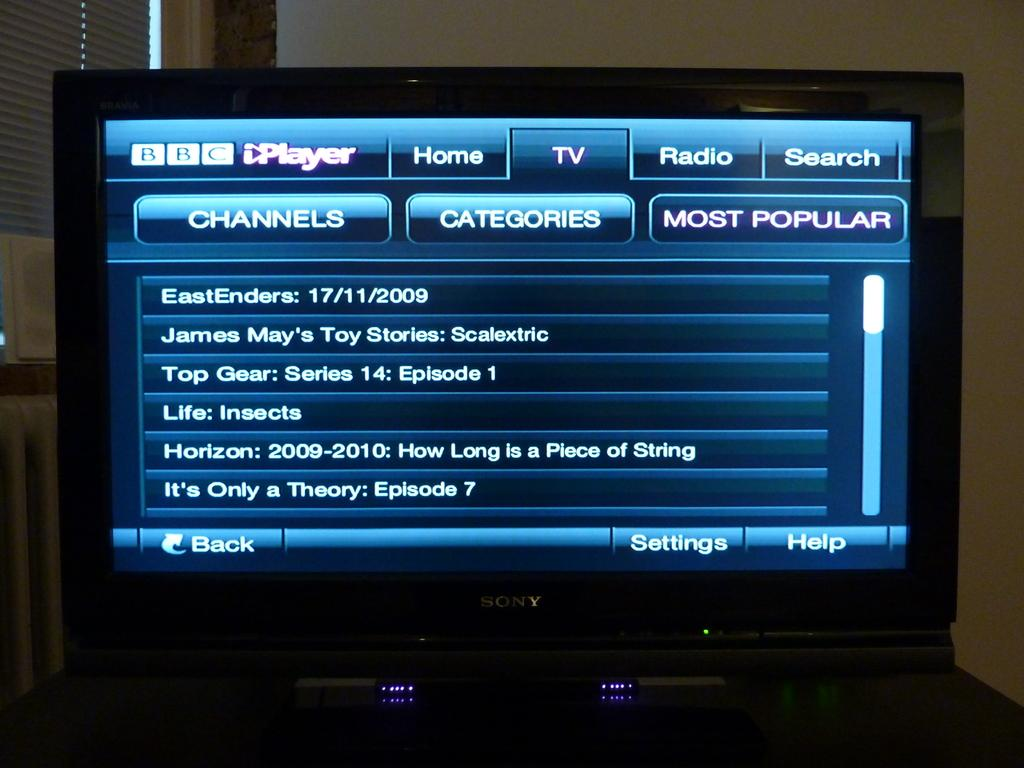<image>
Share a concise interpretation of the image provided. A BBC iPlayer channel guide displayed on a television screen. 